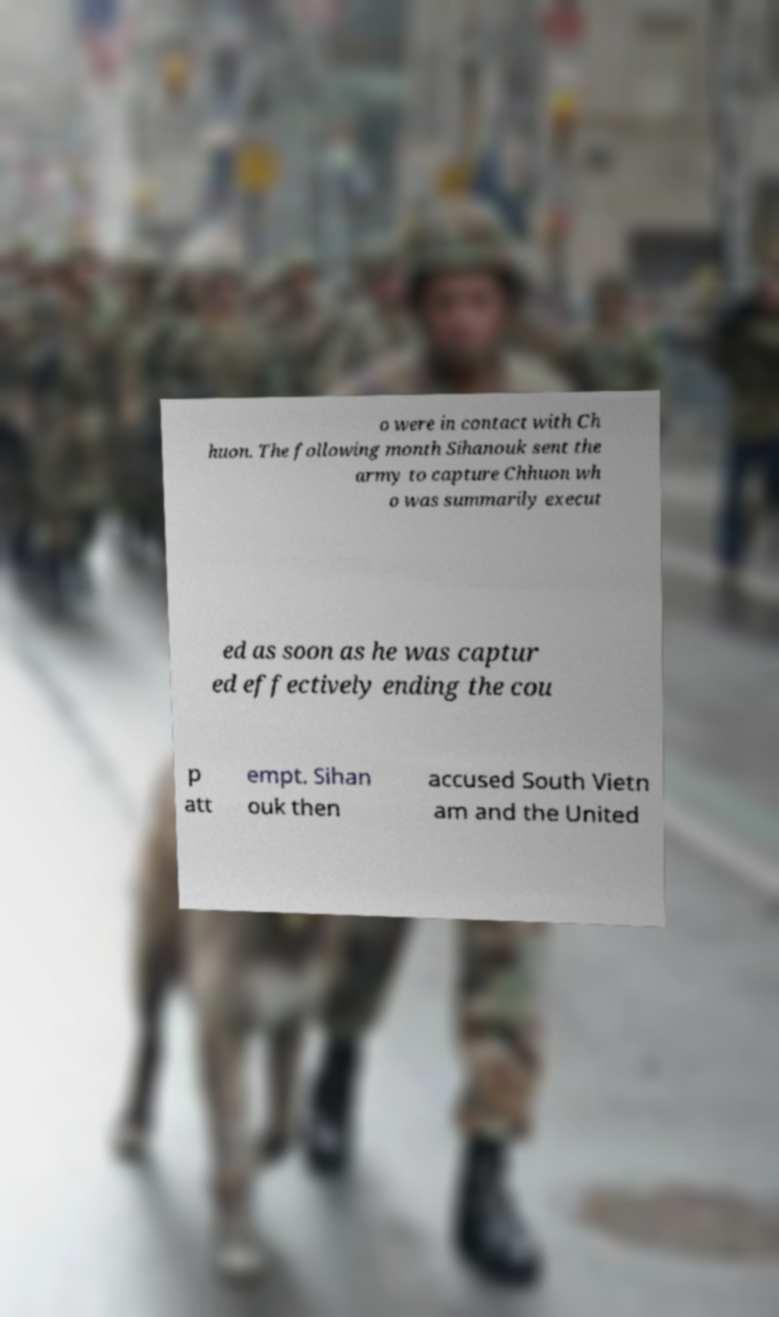Could you extract and type out the text from this image? o were in contact with Ch huon. The following month Sihanouk sent the army to capture Chhuon wh o was summarily execut ed as soon as he was captur ed effectively ending the cou p att empt. Sihan ouk then accused South Vietn am and the United 